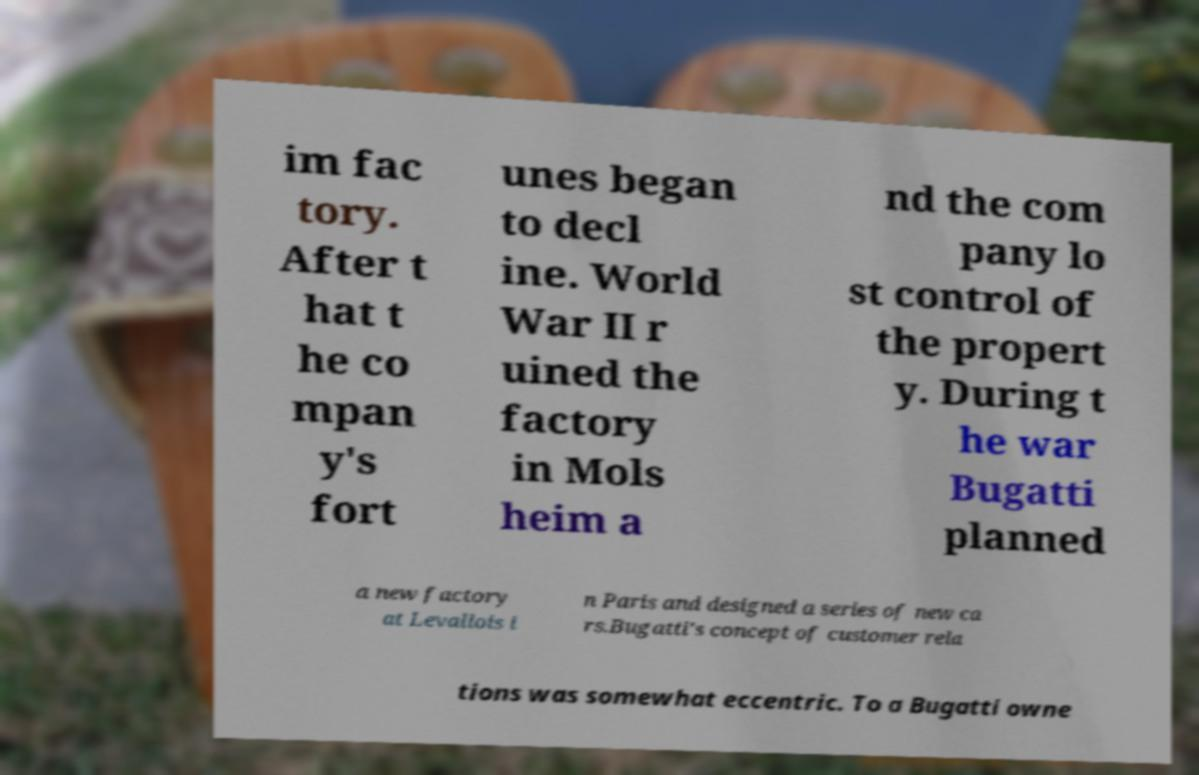Could you assist in decoding the text presented in this image and type it out clearly? im fac tory. After t hat t he co mpan y's fort unes began to decl ine. World War II r uined the factory in Mols heim a nd the com pany lo st control of the propert y. During t he war Bugatti planned a new factory at Levallois i n Paris and designed a series of new ca rs.Bugatti's concept of customer rela tions was somewhat eccentric. To a Bugatti owne 